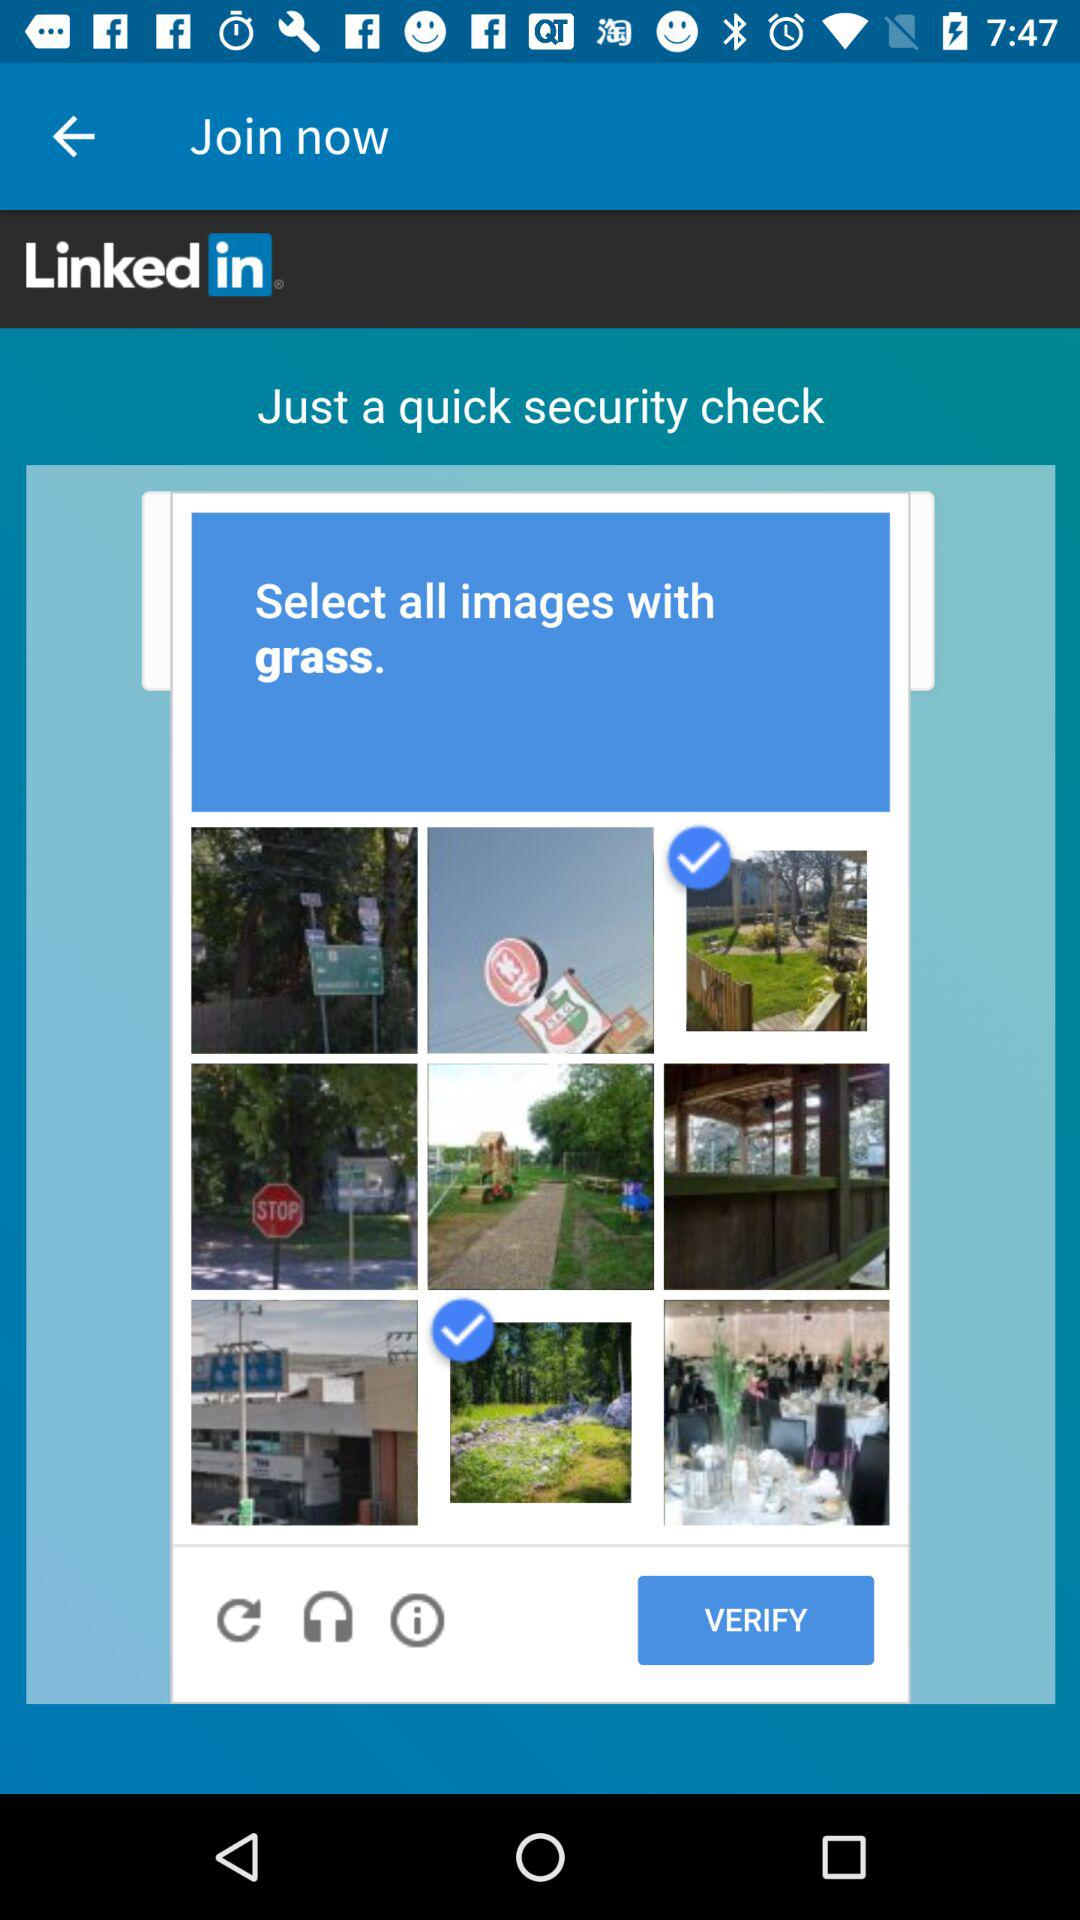What is the name of the application? The name of the app is "Linked in". 